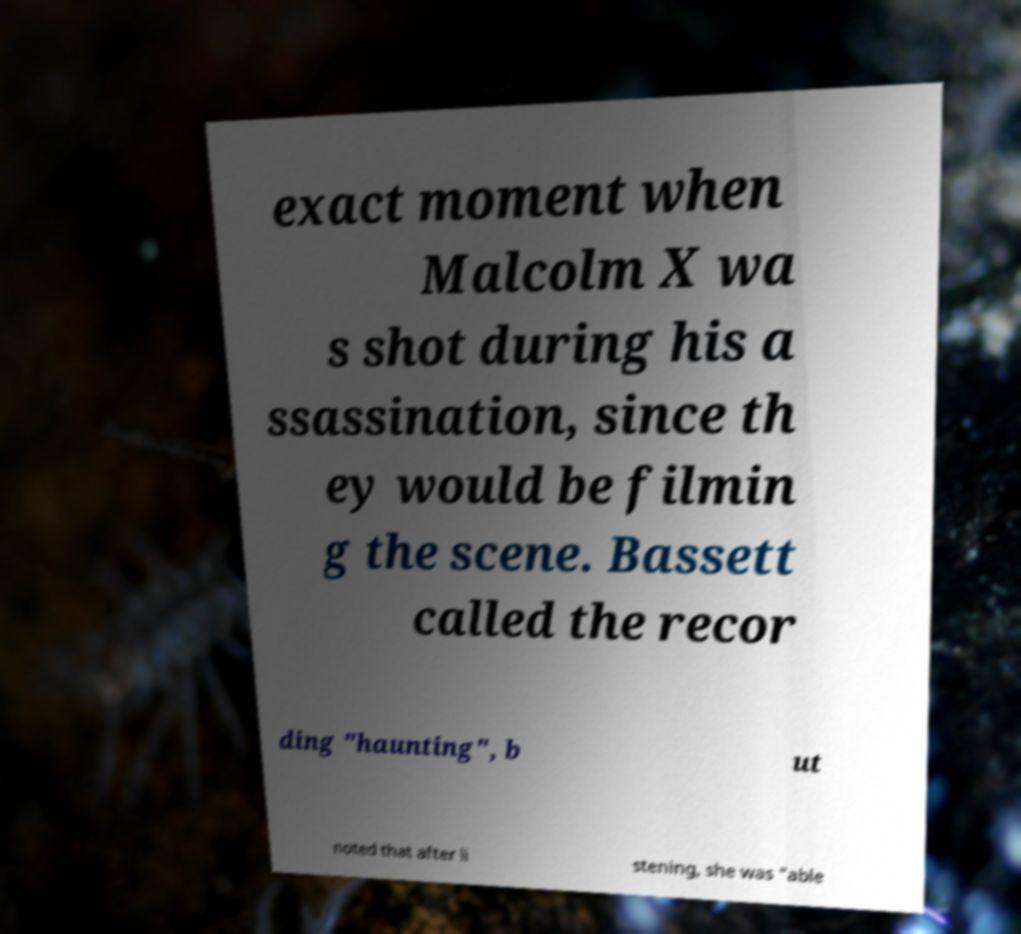Please identify and transcribe the text found in this image. exact moment when Malcolm X wa s shot during his a ssassination, since th ey would be filmin g the scene. Bassett called the recor ding "haunting", b ut noted that after li stening, she was "able 